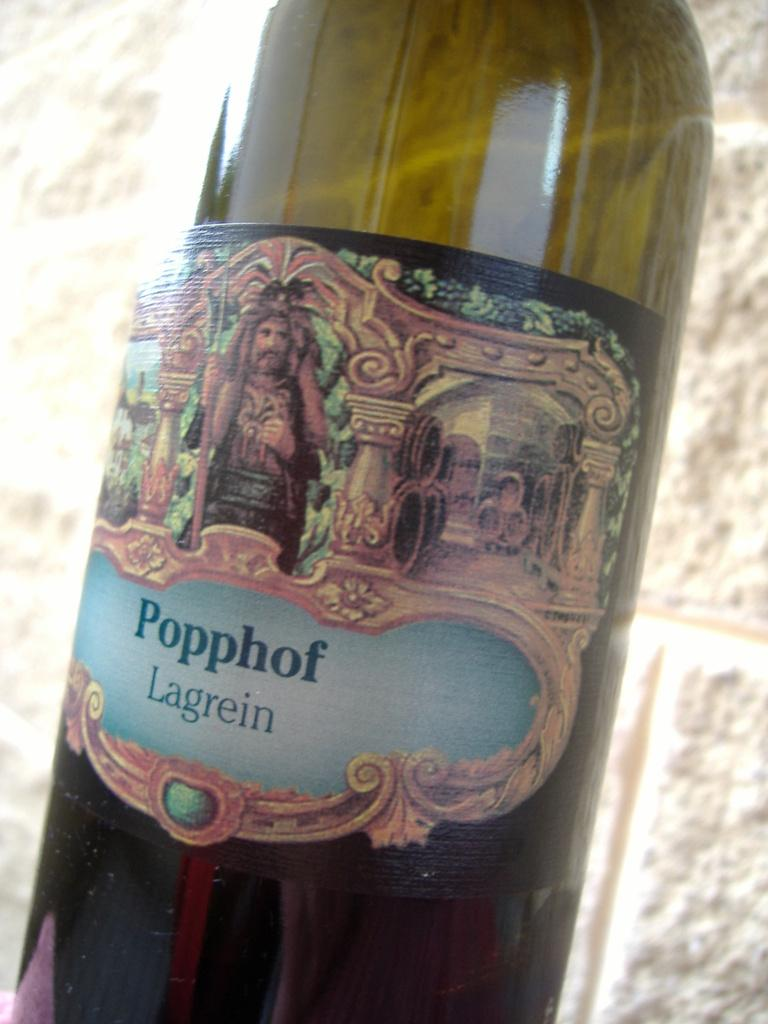<image>
Render a clear and concise summary of the photo. The name of the beverage shown in the glass bottle is Popphof Lagrein. 